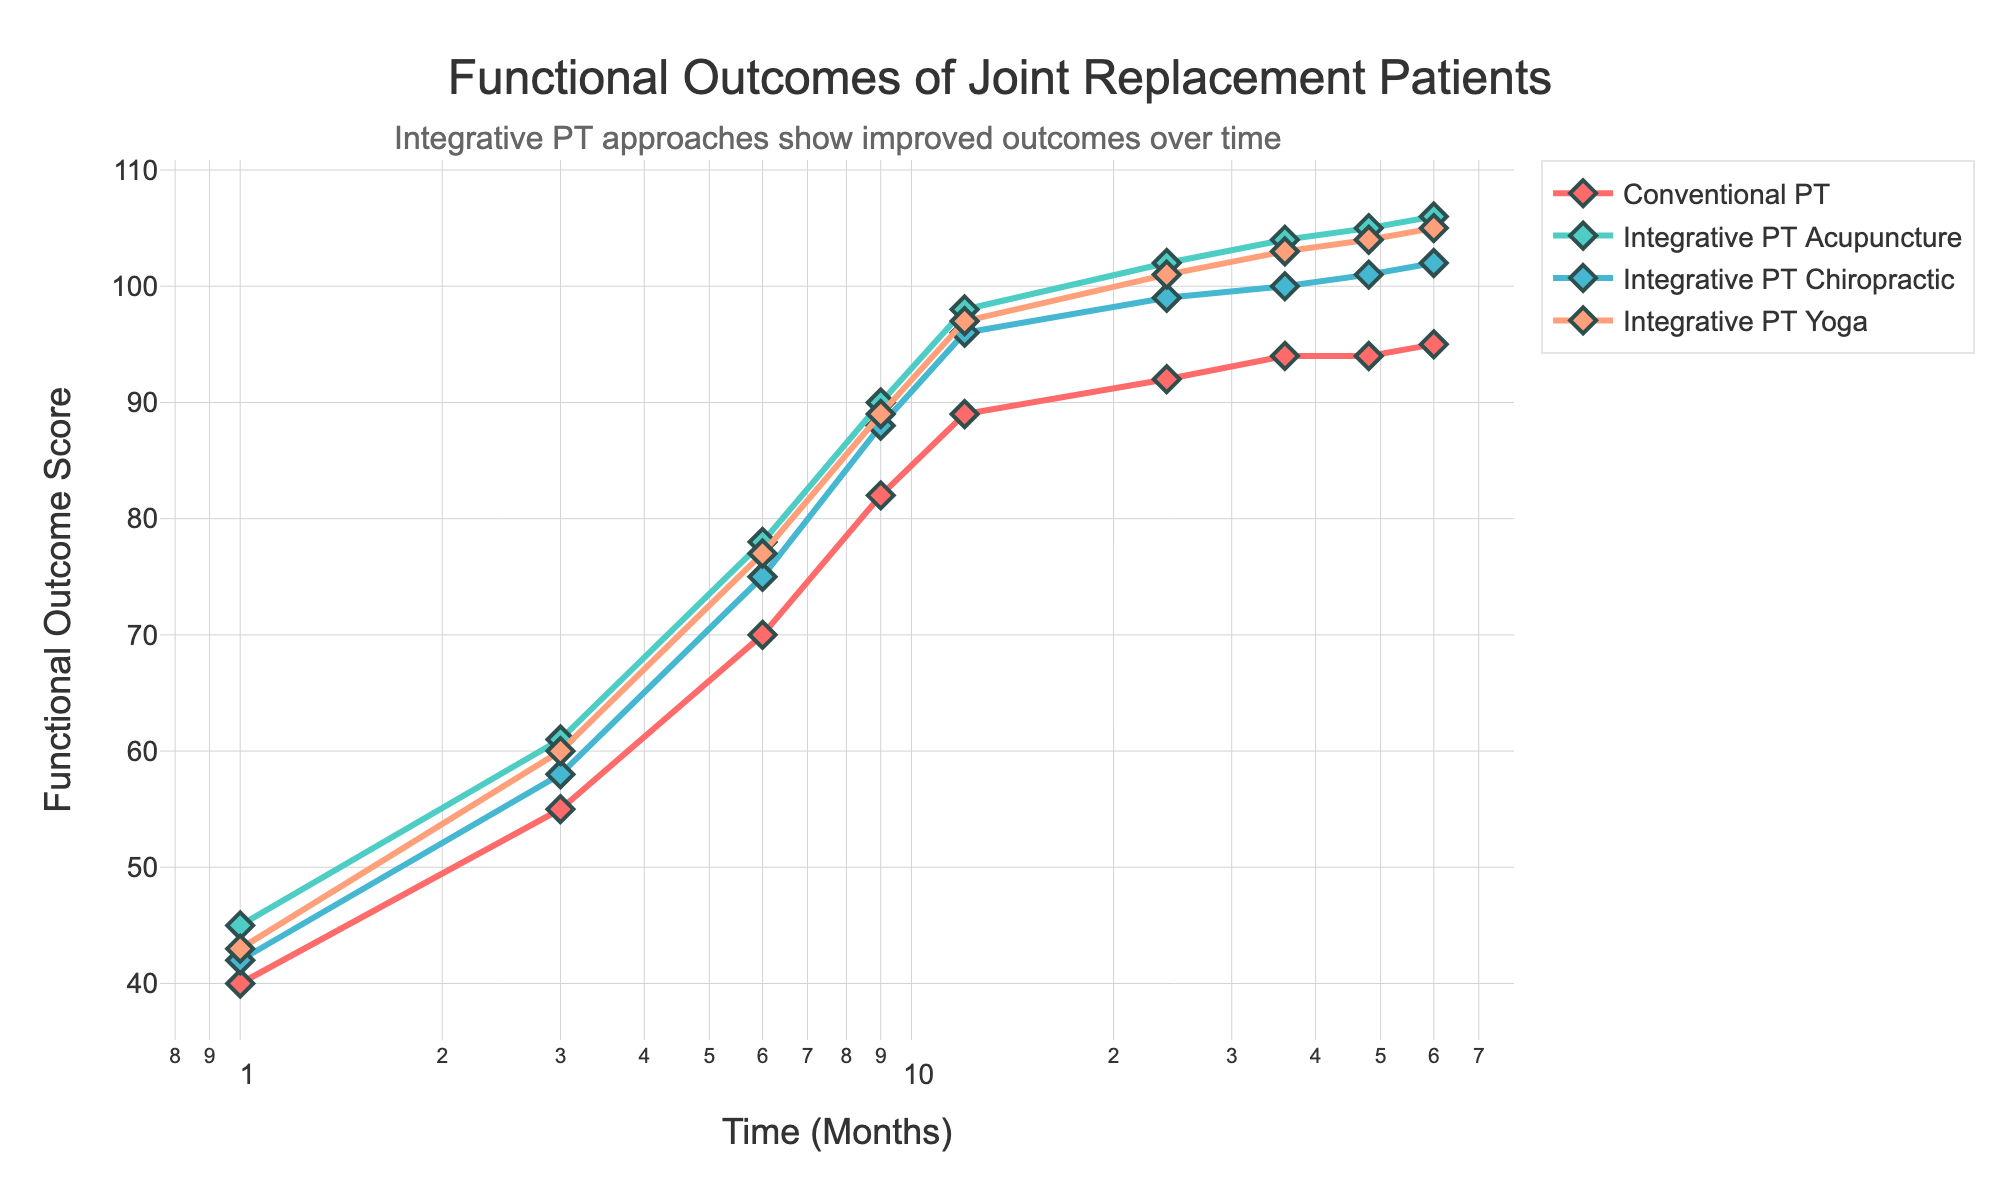What is the title of the plot? The title can be found at the top of the plot, usually in a larger font to draw attention.
Answer: Functional Outcomes of Joint Replacement Patients Which therapy type uses a light blue color for its line? By examining the different colors of the lines, the light blue color corresponds to Integrative Physical Therapy (Chiropractic).
Answer: Integrative PT Chiropractic How many time periods are plotted on the x-axis? The x-axis, labeled 'Time (Months)', has points for each time period where data is recorded. Count these points to find the answer.
Answer: 9 What is the value of the functional outcome score for Conventional Physical Therapy at 24 months? Locate '24' on the x-axis and find the corresponding y-value for the line representing Conventional Physical Therapy.
Answer: 92 Which therapy approach shows the highest functional outcome score at 60 months? Look at the ending points of all lines and find which has the highest y-value. This will indicate the therapy with the highest score.
Answer: Integrative PT Acupuncture How much higher is the functional outcome score for Integrative PT (Yoga) compared to Conventional PT at 9 months? Find the scores for Integrative PT (Yoga) and Conventional PT at 9 months and subtract the Conventional PT score from the Integrative PT (Yoga) score.
Answer: 7 What trend can be observed across all therapy types from 1 to 24 months? Look at the lines from 1 to 24 months; all lines show an increasing trend in functional outcome scores.
Answer: Increasing trend What is the average functional outcome score for Integrative PT (Acupuncture) across all time periods? Add all the scores for Integrative PT (Acupuncture) and divide by the number of time periods (9). (45+61+78+90+98+102+104+105+106)/9 = 876/9 ≈ 97.33
Answer: Approximately 97.33 Between which two time periods does Conventional Physical Therapy show the least improvement in functional outcome scores? Look at the increments in y-values between consecutive periods for Conventional PT and find the smallest increment.
Answer: Between 36 and 48 months 